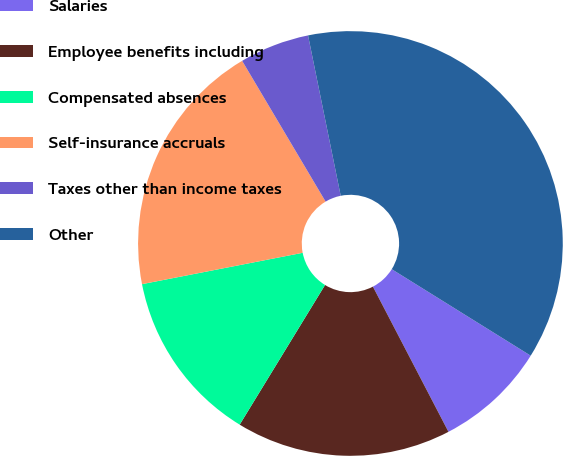<chart> <loc_0><loc_0><loc_500><loc_500><pie_chart><fcel>Salaries<fcel>Employee benefits including<fcel>Compensated absences<fcel>Self-insurance accruals<fcel>Taxes other than income taxes<fcel>Other<nl><fcel>8.5%<fcel>16.37%<fcel>13.2%<fcel>19.55%<fcel>5.32%<fcel>37.06%<nl></chart> 